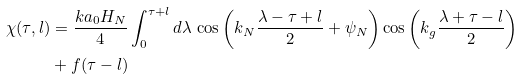Convert formula to latex. <formula><loc_0><loc_0><loc_500><loc_500>\chi ( \tau , l ) & = \frac { k a _ { 0 } H _ { N } } { 4 } \int ^ { \tau + l } _ { 0 } d \lambda \, \cos \left ( k _ { N } \frac { \lambda - \tau + l } { 2 } + \psi _ { N } \right ) \cos \left ( k _ { g } \frac { \lambda + \tau - l } { 2 } \right ) \\ & + f ( \tau - l )</formula> 